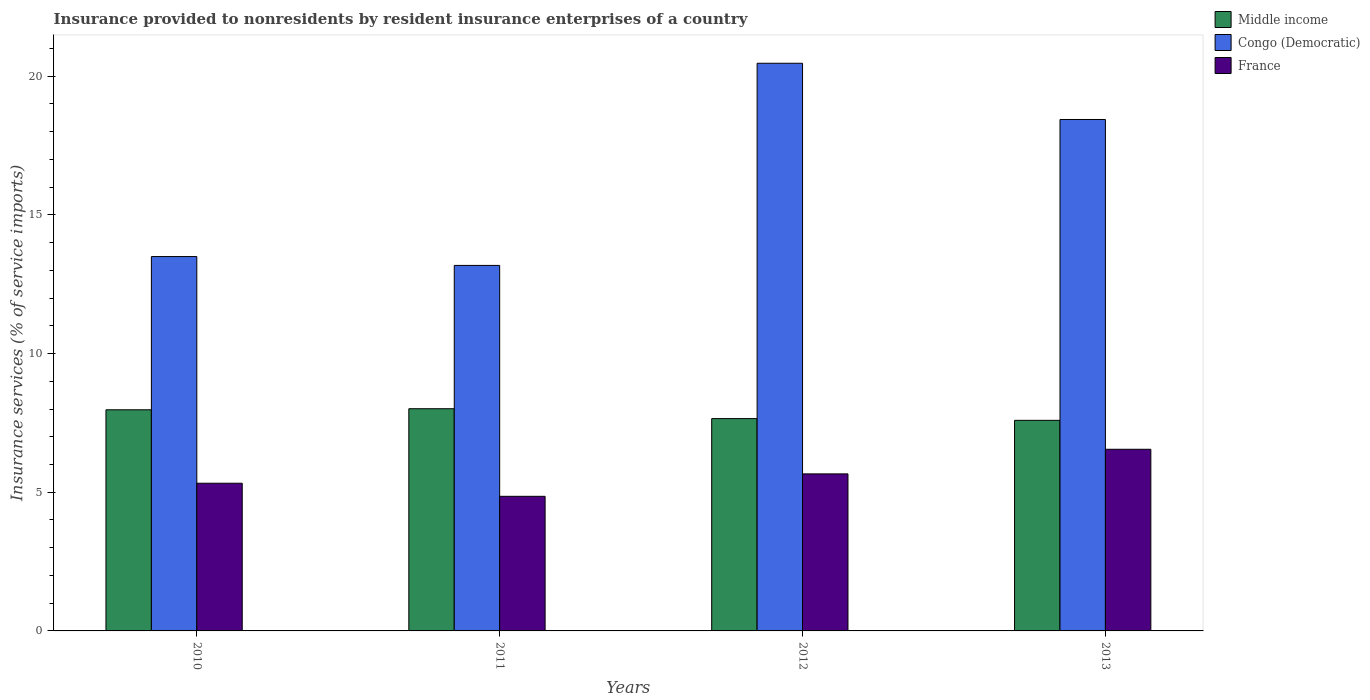How many different coloured bars are there?
Make the answer very short. 3. How many groups of bars are there?
Offer a very short reply. 4. Are the number of bars on each tick of the X-axis equal?
Your answer should be compact. Yes. How many bars are there on the 4th tick from the left?
Ensure brevity in your answer.  3. How many bars are there on the 3rd tick from the right?
Provide a succinct answer. 3. What is the label of the 2nd group of bars from the left?
Ensure brevity in your answer.  2011. In how many cases, is the number of bars for a given year not equal to the number of legend labels?
Ensure brevity in your answer.  0. What is the insurance provided to nonresidents in France in 2012?
Keep it short and to the point. 5.66. Across all years, what is the maximum insurance provided to nonresidents in Congo (Democratic)?
Your answer should be very brief. 20.47. Across all years, what is the minimum insurance provided to nonresidents in France?
Provide a short and direct response. 4.85. In which year was the insurance provided to nonresidents in Middle income maximum?
Make the answer very short. 2011. In which year was the insurance provided to nonresidents in Middle income minimum?
Make the answer very short. 2013. What is the total insurance provided to nonresidents in Congo (Democratic) in the graph?
Provide a succinct answer. 65.58. What is the difference between the insurance provided to nonresidents in Middle income in 2012 and that in 2013?
Provide a succinct answer. 0.06. What is the difference between the insurance provided to nonresidents in Middle income in 2011 and the insurance provided to nonresidents in Congo (Democratic) in 2012?
Offer a terse response. -12.46. What is the average insurance provided to nonresidents in Congo (Democratic) per year?
Your answer should be very brief. 16.4. In the year 2011, what is the difference between the insurance provided to nonresidents in Middle income and insurance provided to nonresidents in France?
Your response must be concise. 3.16. What is the ratio of the insurance provided to nonresidents in Middle income in 2010 to that in 2013?
Provide a short and direct response. 1.05. Is the insurance provided to nonresidents in Middle income in 2011 less than that in 2012?
Provide a short and direct response. No. What is the difference between the highest and the second highest insurance provided to nonresidents in France?
Make the answer very short. 0.89. What is the difference between the highest and the lowest insurance provided to nonresidents in Middle income?
Provide a succinct answer. 0.42. Is the sum of the insurance provided to nonresidents in Middle income in 2010 and 2012 greater than the maximum insurance provided to nonresidents in France across all years?
Ensure brevity in your answer.  Yes. What does the 1st bar from the left in 2013 represents?
Provide a succinct answer. Middle income. Is it the case that in every year, the sum of the insurance provided to nonresidents in France and insurance provided to nonresidents in Middle income is greater than the insurance provided to nonresidents in Congo (Democratic)?
Give a very brief answer. No. How many bars are there?
Make the answer very short. 12. Are all the bars in the graph horizontal?
Ensure brevity in your answer.  No. What is the difference between two consecutive major ticks on the Y-axis?
Your answer should be very brief. 5. Does the graph contain any zero values?
Ensure brevity in your answer.  No. How many legend labels are there?
Ensure brevity in your answer.  3. How are the legend labels stacked?
Your answer should be very brief. Vertical. What is the title of the graph?
Make the answer very short. Insurance provided to nonresidents by resident insurance enterprises of a country. Does "Sao Tome and Principe" appear as one of the legend labels in the graph?
Your answer should be compact. No. What is the label or title of the X-axis?
Keep it short and to the point. Years. What is the label or title of the Y-axis?
Your answer should be very brief. Insurance services (% of service imports). What is the Insurance services (% of service imports) of Middle income in 2010?
Give a very brief answer. 7.97. What is the Insurance services (% of service imports) in Congo (Democratic) in 2010?
Make the answer very short. 13.5. What is the Insurance services (% of service imports) in France in 2010?
Your response must be concise. 5.32. What is the Insurance services (% of service imports) of Middle income in 2011?
Provide a short and direct response. 8.01. What is the Insurance services (% of service imports) of Congo (Democratic) in 2011?
Offer a terse response. 13.18. What is the Insurance services (% of service imports) of France in 2011?
Your answer should be compact. 4.85. What is the Insurance services (% of service imports) in Middle income in 2012?
Your answer should be very brief. 7.66. What is the Insurance services (% of service imports) of Congo (Democratic) in 2012?
Provide a short and direct response. 20.47. What is the Insurance services (% of service imports) of France in 2012?
Ensure brevity in your answer.  5.66. What is the Insurance services (% of service imports) of Middle income in 2013?
Your answer should be very brief. 7.59. What is the Insurance services (% of service imports) in Congo (Democratic) in 2013?
Ensure brevity in your answer.  18.44. What is the Insurance services (% of service imports) of France in 2013?
Make the answer very short. 6.55. Across all years, what is the maximum Insurance services (% of service imports) in Middle income?
Your response must be concise. 8.01. Across all years, what is the maximum Insurance services (% of service imports) of Congo (Democratic)?
Keep it short and to the point. 20.47. Across all years, what is the maximum Insurance services (% of service imports) in France?
Offer a very short reply. 6.55. Across all years, what is the minimum Insurance services (% of service imports) of Middle income?
Offer a very short reply. 7.59. Across all years, what is the minimum Insurance services (% of service imports) in Congo (Democratic)?
Make the answer very short. 13.18. Across all years, what is the minimum Insurance services (% of service imports) in France?
Make the answer very short. 4.85. What is the total Insurance services (% of service imports) in Middle income in the graph?
Offer a terse response. 31.23. What is the total Insurance services (% of service imports) of Congo (Democratic) in the graph?
Your answer should be compact. 65.58. What is the total Insurance services (% of service imports) in France in the graph?
Your answer should be very brief. 22.39. What is the difference between the Insurance services (% of service imports) in Middle income in 2010 and that in 2011?
Ensure brevity in your answer.  -0.04. What is the difference between the Insurance services (% of service imports) in Congo (Democratic) in 2010 and that in 2011?
Your response must be concise. 0.32. What is the difference between the Insurance services (% of service imports) of France in 2010 and that in 2011?
Ensure brevity in your answer.  0.47. What is the difference between the Insurance services (% of service imports) in Middle income in 2010 and that in 2012?
Keep it short and to the point. 0.32. What is the difference between the Insurance services (% of service imports) in Congo (Democratic) in 2010 and that in 2012?
Offer a terse response. -6.97. What is the difference between the Insurance services (% of service imports) of France in 2010 and that in 2012?
Your answer should be very brief. -0.34. What is the difference between the Insurance services (% of service imports) of Middle income in 2010 and that in 2013?
Offer a very short reply. 0.38. What is the difference between the Insurance services (% of service imports) of Congo (Democratic) in 2010 and that in 2013?
Keep it short and to the point. -4.94. What is the difference between the Insurance services (% of service imports) of France in 2010 and that in 2013?
Offer a terse response. -1.22. What is the difference between the Insurance services (% of service imports) in Middle income in 2011 and that in 2012?
Provide a short and direct response. 0.36. What is the difference between the Insurance services (% of service imports) of Congo (Democratic) in 2011 and that in 2012?
Keep it short and to the point. -7.29. What is the difference between the Insurance services (% of service imports) of France in 2011 and that in 2012?
Your answer should be very brief. -0.81. What is the difference between the Insurance services (% of service imports) in Middle income in 2011 and that in 2013?
Offer a terse response. 0.42. What is the difference between the Insurance services (% of service imports) of Congo (Democratic) in 2011 and that in 2013?
Your answer should be compact. -5.26. What is the difference between the Insurance services (% of service imports) in France in 2011 and that in 2013?
Ensure brevity in your answer.  -1.7. What is the difference between the Insurance services (% of service imports) of Middle income in 2012 and that in 2013?
Give a very brief answer. 0.06. What is the difference between the Insurance services (% of service imports) in Congo (Democratic) in 2012 and that in 2013?
Offer a terse response. 2.03. What is the difference between the Insurance services (% of service imports) of France in 2012 and that in 2013?
Your answer should be very brief. -0.89. What is the difference between the Insurance services (% of service imports) in Middle income in 2010 and the Insurance services (% of service imports) in Congo (Democratic) in 2011?
Offer a terse response. -5.21. What is the difference between the Insurance services (% of service imports) in Middle income in 2010 and the Insurance services (% of service imports) in France in 2011?
Make the answer very short. 3.12. What is the difference between the Insurance services (% of service imports) of Congo (Democratic) in 2010 and the Insurance services (% of service imports) of France in 2011?
Your answer should be compact. 8.64. What is the difference between the Insurance services (% of service imports) in Middle income in 2010 and the Insurance services (% of service imports) in Congo (Democratic) in 2012?
Your answer should be very brief. -12.49. What is the difference between the Insurance services (% of service imports) in Middle income in 2010 and the Insurance services (% of service imports) in France in 2012?
Keep it short and to the point. 2.31. What is the difference between the Insurance services (% of service imports) in Congo (Democratic) in 2010 and the Insurance services (% of service imports) in France in 2012?
Offer a very short reply. 7.84. What is the difference between the Insurance services (% of service imports) in Middle income in 2010 and the Insurance services (% of service imports) in Congo (Democratic) in 2013?
Your answer should be very brief. -10.47. What is the difference between the Insurance services (% of service imports) of Middle income in 2010 and the Insurance services (% of service imports) of France in 2013?
Your response must be concise. 1.42. What is the difference between the Insurance services (% of service imports) of Congo (Democratic) in 2010 and the Insurance services (% of service imports) of France in 2013?
Your response must be concise. 6.95. What is the difference between the Insurance services (% of service imports) of Middle income in 2011 and the Insurance services (% of service imports) of Congo (Democratic) in 2012?
Your response must be concise. -12.46. What is the difference between the Insurance services (% of service imports) of Middle income in 2011 and the Insurance services (% of service imports) of France in 2012?
Your response must be concise. 2.35. What is the difference between the Insurance services (% of service imports) of Congo (Democratic) in 2011 and the Insurance services (% of service imports) of France in 2012?
Your answer should be compact. 7.52. What is the difference between the Insurance services (% of service imports) of Middle income in 2011 and the Insurance services (% of service imports) of Congo (Democratic) in 2013?
Your answer should be compact. -10.43. What is the difference between the Insurance services (% of service imports) in Middle income in 2011 and the Insurance services (% of service imports) in France in 2013?
Offer a terse response. 1.46. What is the difference between the Insurance services (% of service imports) of Congo (Democratic) in 2011 and the Insurance services (% of service imports) of France in 2013?
Keep it short and to the point. 6.63. What is the difference between the Insurance services (% of service imports) of Middle income in 2012 and the Insurance services (% of service imports) of Congo (Democratic) in 2013?
Offer a terse response. -10.78. What is the difference between the Insurance services (% of service imports) in Middle income in 2012 and the Insurance services (% of service imports) in France in 2013?
Offer a terse response. 1.11. What is the difference between the Insurance services (% of service imports) of Congo (Democratic) in 2012 and the Insurance services (% of service imports) of France in 2013?
Provide a succinct answer. 13.92. What is the average Insurance services (% of service imports) in Middle income per year?
Provide a succinct answer. 7.81. What is the average Insurance services (% of service imports) in Congo (Democratic) per year?
Offer a very short reply. 16.4. What is the average Insurance services (% of service imports) of France per year?
Your response must be concise. 5.6. In the year 2010, what is the difference between the Insurance services (% of service imports) in Middle income and Insurance services (% of service imports) in Congo (Democratic)?
Give a very brief answer. -5.52. In the year 2010, what is the difference between the Insurance services (% of service imports) in Middle income and Insurance services (% of service imports) in France?
Offer a very short reply. 2.65. In the year 2010, what is the difference between the Insurance services (% of service imports) of Congo (Democratic) and Insurance services (% of service imports) of France?
Provide a succinct answer. 8.17. In the year 2011, what is the difference between the Insurance services (% of service imports) in Middle income and Insurance services (% of service imports) in Congo (Democratic)?
Offer a very short reply. -5.17. In the year 2011, what is the difference between the Insurance services (% of service imports) of Middle income and Insurance services (% of service imports) of France?
Offer a terse response. 3.16. In the year 2011, what is the difference between the Insurance services (% of service imports) in Congo (Democratic) and Insurance services (% of service imports) in France?
Provide a short and direct response. 8.33. In the year 2012, what is the difference between the Insurance services (% of service imports) of Middle income and Insurance services (% of service imports) of Congo (Democratic)?
Keep it short and to the point. -12.81. In the year 2012, what is the difference between the Insurance services (% of service imports) in Middle income and Insurance services (% of service imports) in France?
Your answer should be very brief. 1.99. In the year 2012, what is the difference between the Insurance services (% of service imports) of Congo (Democratic) and Insurance services (% of service imports) of France?
Make the answer very short. 14.81. In the year 2013, what is the difference between the Insurance services (% of service imports) in Middle income and Insurance services (% of service imports) in Congo (Democratic)?
Give a very brief answer. -10.85. In the year 2013, what is the difference between the Insurance services (% of service imports) of Middle income and Insurance services (% of service imports) of France?
Provide a short and direct response. 1.04. In the year 2013, what is the difference between the Insurance services (% of service imports) of Congo (Democratic) and Insurance services (% of service imports) of France?
Offer a very short reply. 11.89. What is the ratio of the Insurance services (% of service imports) of Middle income in 2010 to that in 2011?
Give a very brief answer. 1. What is the ratio of the Insurance services (% of service imports) of Congo (Democratic) in 2010 to that in 2011?
Make the answer very short. 1.02. What is the ratio of the Insurance services (% of service imports) of France in 2010 to that in 2011?
Offer a very short reply. 1.1. What is the ratio of the Insurance services (% of service imports) of Middle income in 2010 to that in 2012?
Your answer should be compact. 1.04. What is the ratio of the Insurance services (% of service imports) of Congo (Democratic) in 2010 to that in 2012?
Give a very brief answer. 0.66. What is the ratio of the Insurance services (% of service imports) of France in 2010 to that in 2012?
Your answer should be very brief. 0.94. What is the ratio of the Insurance services (% of service imports) of Middle income in 2010 to that in 2013?
Your answer should be compact. 1.05. What is the ratio of the Insurance services (% of service imports) in Congo (Democratic) in 2010 to that in 2013?
Keep it short and to the point. 0.73. What is the ratio of the Insurance services (% of service imports) of France in 2010 to that in 2013?
Keep it short and to the point. 0.81. What is the ratio of the Insurance services (% of service imports) in Middle income in 2011 to that in 2012?
Ensure brevity in your answer.  1.05. What is the ratio of the Insurance services (% of service imports) in Congo (Democratic) in 2011 to that in 2012?
Provide a short and direct response. 0.64. What is the ratio of the Insurance services (% of service imports) in France in 2011 to that in 2012?
Provide a succinct answer. 0.86. What is the ratio of the Insurance services (% of service imports) of Middle income in 2011 to that in 2013?
Give a very brief answer. 1.06. What is the ratio of the Insurance services (% of service imports) of Congo (Democratic) in 2011 to that in 2013?
Offer a terse response. 0.71. What is the ratio of the Insurance services (% of service imports) in France in 2011 to that in 2013?
Your response must be concise. 0.74. What is the ratio of the Insurance services (% of service imports) in Middle income in 2012 to that in 2013?
Your answer should be very brief. 1.01. What is the ratio of the Insurance services (% of service imports) in Congo (Democratic) in 2012 to that in 2013?
Give a very brief answer. 1.11. What is the ratio of the Insurance services (% of service imports) in France in 2012 to that in 2013?
Keep it short and to the point. 0.86. What is the difference between the highest and the second highest Insurance services (% of service imports) in Middle income?
Provide a succinct answer. 0.04. What is the difference between the highest and the second highest Insurance services (% of service imports) in Congo (Democratic)?
Provide a succinct answer. 2.03. What is the difference between the highest and the second highest Insurance services (% of service imports) in France?
Ensure brevity in your answer.  0.89. What is the difference between the highest and the lowest Insurance services (% of service imports) in Middle income?
Your response must be concise. 0.42. What is the difference between the highest and the lowest Insurance services (% of service imports) of Congo (Democratic)?
Provide a succinct answer. 7.29. What is the difference between the highest and the lowest Insurance services (% of service imports) in France?
Your response must be concise. 1.7. 